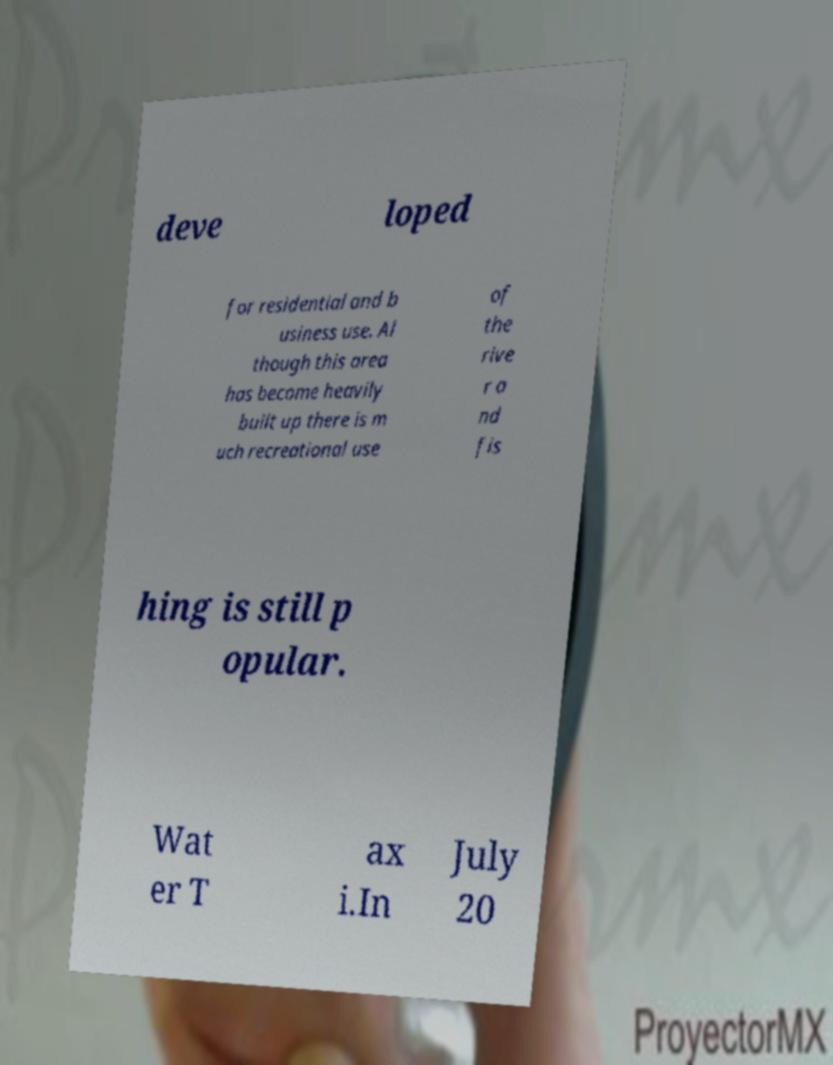There's text embedded in this image that I need extracted. Can you transcribe it verbatim? deve loped for residential and b usiness use. Al though this area has become heavily built up there is m uch recreational use of the rive r a nd fis hing is still p opular. Wat er T ax i.In July 20 